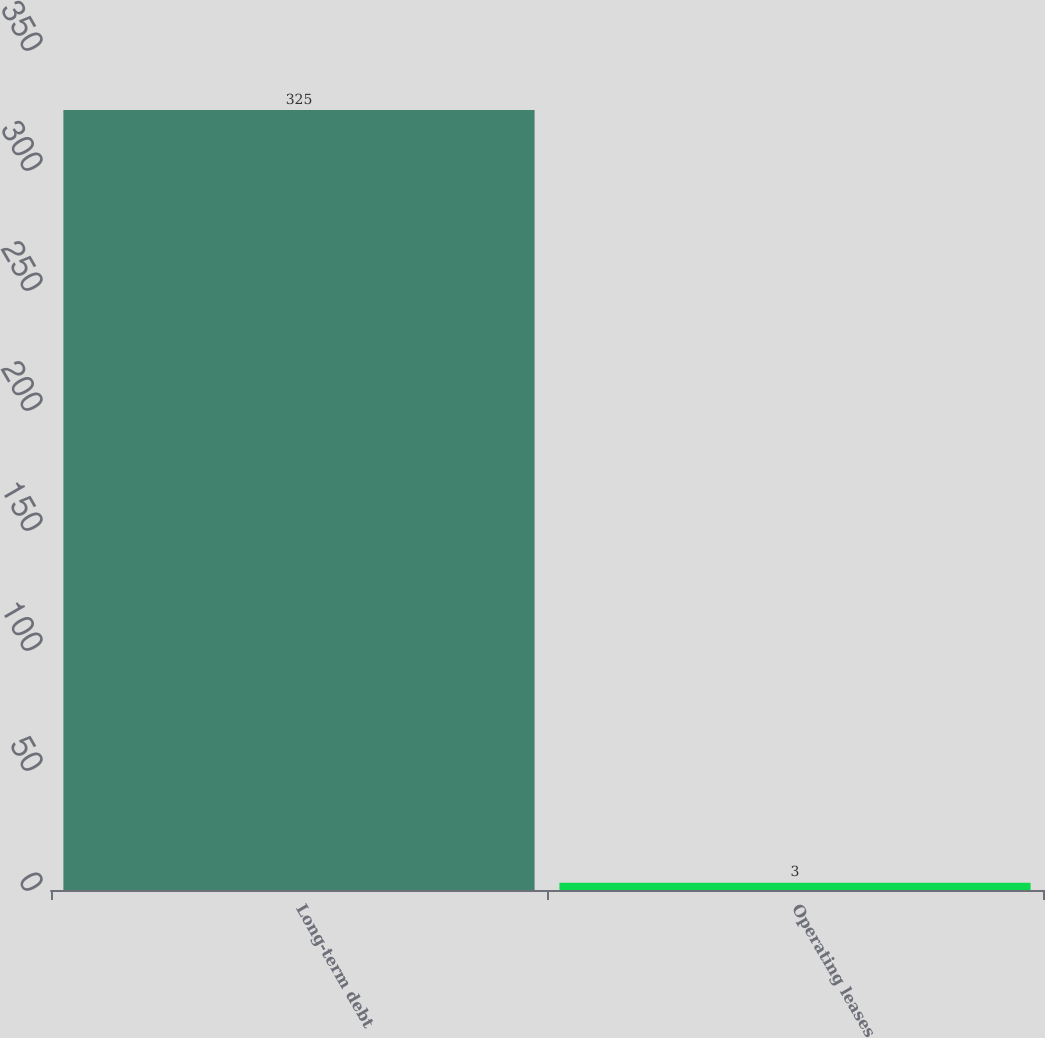<chart> <loc_0><loc_0><loc_500><loc_500><bar_chart><fcel>Long-term debt<fcel>Operating leases<nl><fcel>325<fcel>3<nl></chart> 